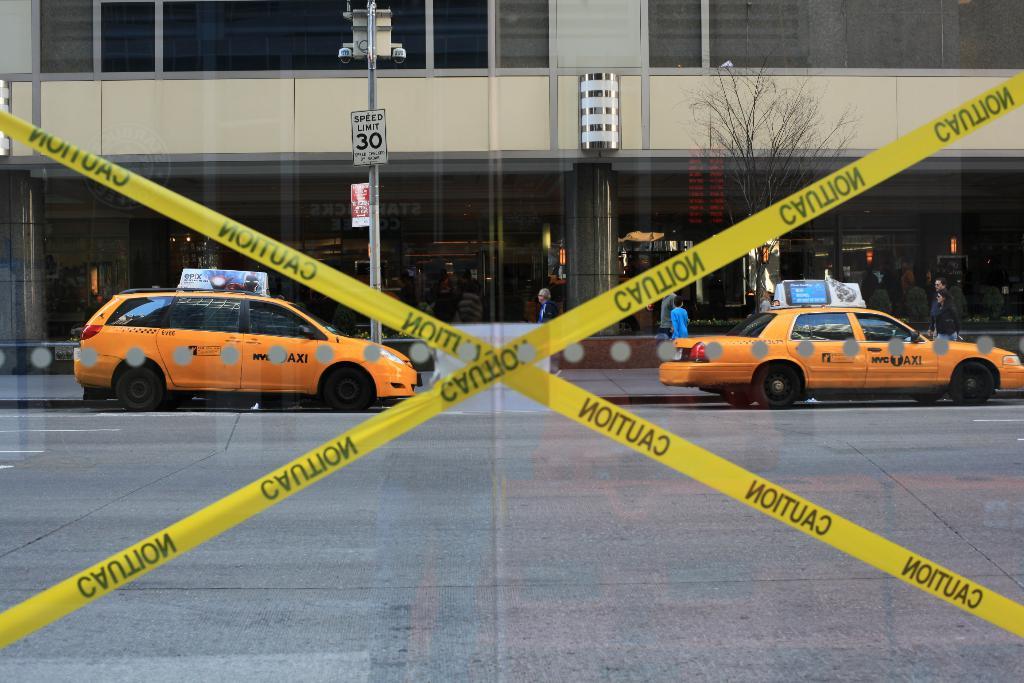Is that caution tape?
Provide a succinct answer. Yes. What city are the taxis from?
Your response must be concise. Nyc. 